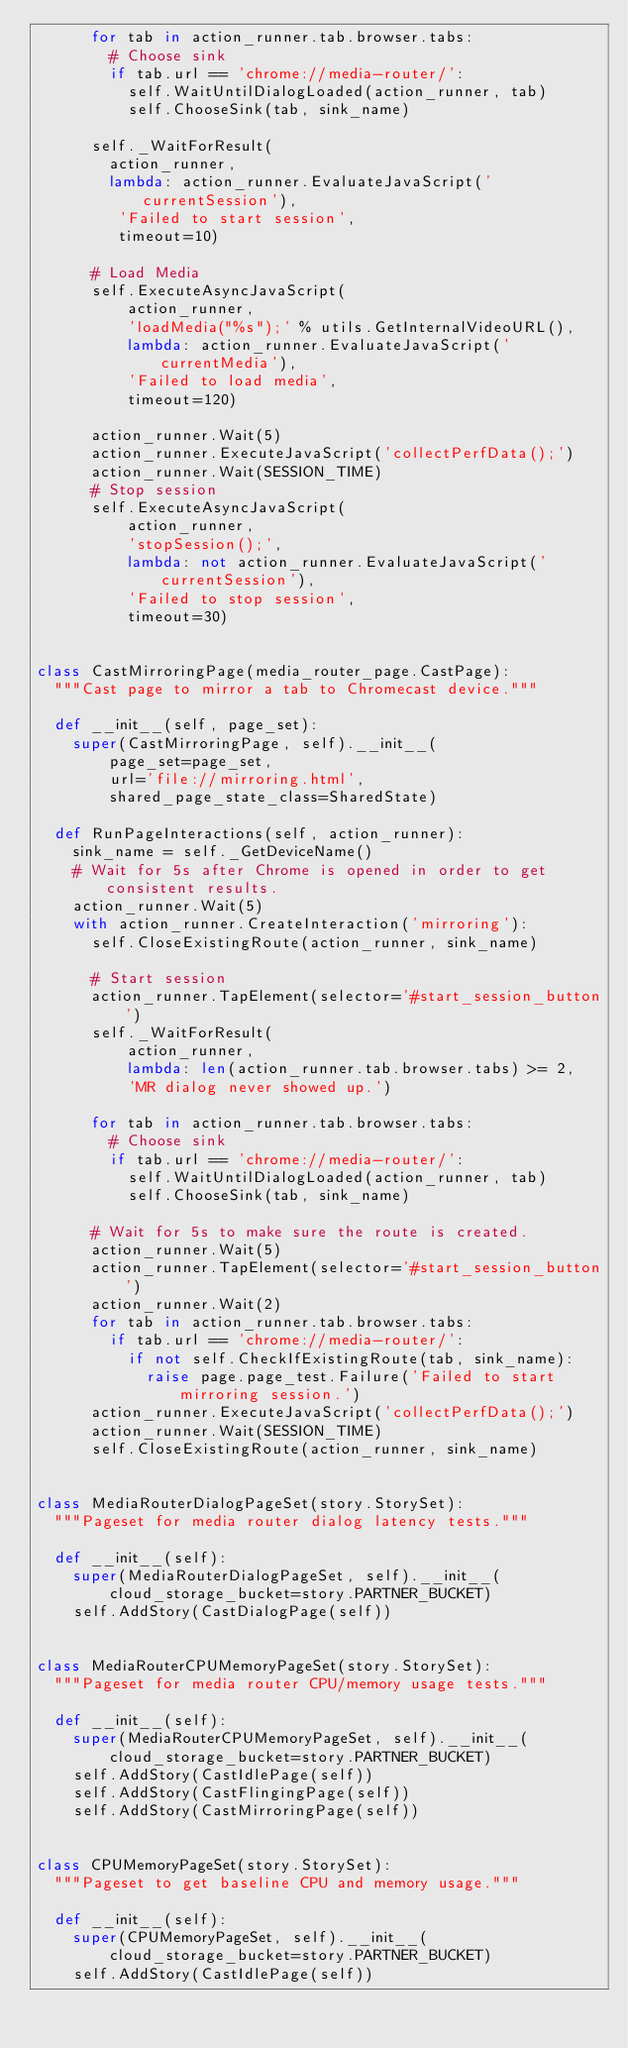<code> <loc_0><loc_0><loc_500><loc_500><_Python_>      for tab in action_runner.tab.browser.tabs:
        # Choose sink
        if tab.url == 'chrome://media-router/':
          self.WaitUntilDialogLoaded(action_runner, tab)
          self.ChooseSink(tab, sink_name)

      self._WaitForResult(
        action_runner,
        lambda: action_runner.EvaluateJavaScript('currentSession'),
         'Failed to start session',
         timeout=10)

      # Load Media
      self.ExecuteAsyncJavaScript(
          action_runner,
          'loadMedia("%s");' % utils.GetInternalVideoURL(),
          lambda: action_runner.EvaluateJavaScript('currentMedia'),
          'Failed to load media',
          timeout=120)

      action_runner.Wait(5)
      action_runner.ExecuteJavaScript('collectPerfData();')
      action_runner.Wait(SESSION_TIME)
      # Stop session
      self.ExecuteAsyncJavaScript(
          action_runner,
          'stopSession();',
          lambda: not action_runner.EvaluateJavaScript('currentSession'),
          'Failed to stop session',
          timeout=30)


class CastMirroringPage(media_router_page.CastPage):
  """Cast page to mirror a tab to Chromecast device."""

  def __init__(self, page_set):
    super(CastMirroringPage, self).__init__(
        page_set=page_set,
        url='file://mirroring.html',
        shared_page_state_class=SharedState)

  def RunPageInteractions(self, action_runner):
    sink_name = self._GetDeviceName()
    # Wait for 5s after Chrome is opened in order to get consistent results.
    action_runner.Wait(5)
    with action_runner.CreateInteraction('mirroring'):
      self.CloseExistingRoute(action_runner, sink_name)

      # Start session
      action_runner.TapElement(selector='#start_session_button')
      self._WaitForResult(
          action_runner,
          lambda: len(action_runner.tab.browser.tabs) >= 2,
          'MR dialog never showed up.')

      for tab in action_runner.tab.browser.tabs:
        # Choose sink
        if tab.url == 'chrome://media-router/':
          self.WaitUntilDialogLoaded(action_runner, tab)
          self.ChooseSink(tab, sink_name)

      # Wait for 5s to make sure the route is created.
      action_runner.Wait(5)
      action_runner.TapElement(selector='#start_session_button')
      action_runner.Wait(2)
      for tab in action_runner.tab.browser.tabs:
        if tab.url == 'chrome://media-router/':
          if not self.CheckIfExistingRoute(tab, sink_name):
            raise page.page_test.Failure('Failed to start mirroring session.')
      action_runner.ExecuteJavaScript('collectPerfData();')
      action_runner.Wait(SESSION_TIME)
      self.CloseExistingRoute(action_runner, sink_name)


class MediaRouterDialogPageSet(story.StorySet):
  """Pageset for media router dialog latency tests."""

  def __init__(self):
    super(MediaRouterDialogPageSet, self).__init__(
        cloud_storage_bucket=story.PARTNER_BUCKET)
    self.AddStory(CastDialogPage(self))


class MediaRouterCPUMemoryPageSet(story.StorySet):
  """Pageset for media router CPU/memory usage tests."""

  def __init__(self):
    super(MediaRouterCPUMemoryPageSet, self).__init__(
        cloud_storage_bucket=story.PARTNER_BUCKET)
    self.AddStory(CastIdlePage(self))
    self.AddStory(CastFlingingPage(self))
    self.AddStory(CastMirroringPage(self))


class CPUMemoryPageSet(story.StorySet):
  """Pageset to get baseline CPU and memory usage."""

  def __init__(self):
    super(CPUMemoryPageSet, self).__init__(
        cloud_storage_bucket=story.PARTNER_BUCKET)
    self.AddStory(CastIdlePage(self))
</code> 